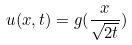<formula> <loc_0><loc_0><loc_500><loc_500>u ( x , t ) = g ( \frac { x } { \sqrt { 2 t } } )</formula> 